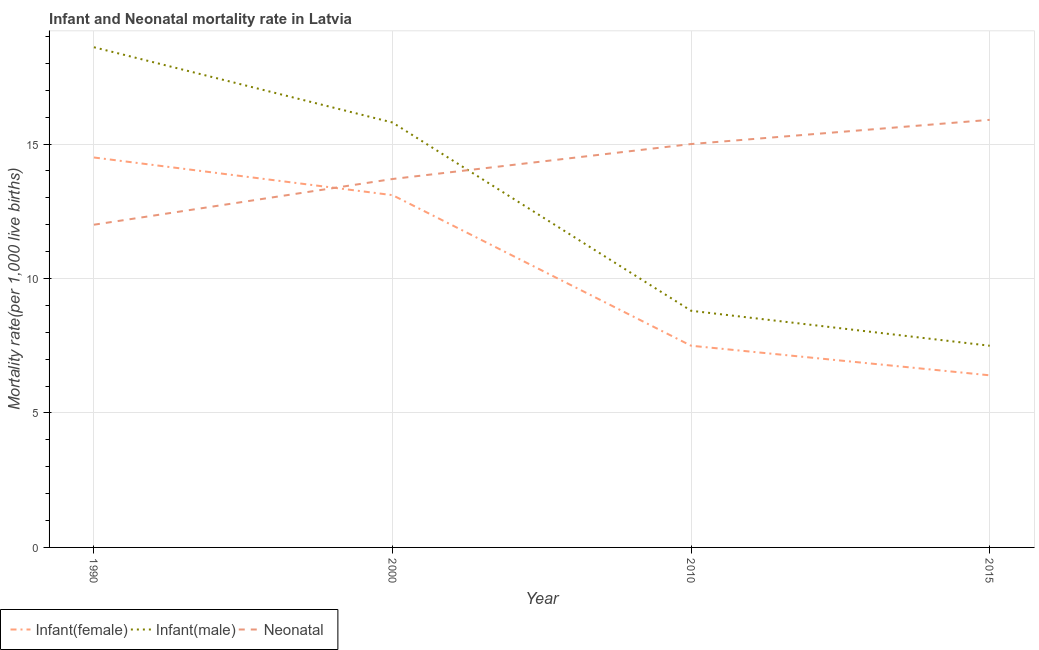How many different coloured lines are there?
Provide a succinct answer. 3. Is the number of lines equal to the number of legend labels?
Your response must be concise. Yes. What is the infant mortality rate(male) in 2015?
Your response must be concise. 7.5. Across all years, what is the maximum infant mortality rate(male)?
Your answer should be compact. 18.6. Across all years, what is the minimum neonatal mortality rate?
Ensure brevity in your answer.  12. In which year was the infant mortality rate(male) maximum?
Your response must be concise. 1990. In which year was the neonatal mortality rate minimum?
Make the answer very short. 1990. What is the total infant mortality rate(female) in the graph?
Your response must be concise. 41.5. What is the difference between the infant mortality rate(female) in 2010 and that in 2015?
Give a very brief answer. 1.1. What is the difference between the neonatal mortality rate in 1990 and the infant mortality rate(male) in 2000?
Your answer should be very brief. -3.8. What is the average infant mortality rate(male) per year?
Provide a short and direct response. 12.68. In the year 2000, what is the difference between the neonatal mortality rate and infant mortality rate(male)?
Your response must be concise. -2.1. What is the ratio of the infant mortality rate(female) in 1990 to that in 2010?
Provide a short and direct response. 1.93. Is the difference between the neonatal mortality rate in 2000 and 2010 greater than the difference between the infant mortality rate(male) in 2000 and 2010?
Provide a succinct answer. No. What is the difference between the highest and the second highest infant mortality rate(male)?
Offer a very short reply. 2.8. What is the difference between the highest and the lowest neonatal mortality rate?
Your answer should be compact. 3.9. In how many years, is the infant mortality rate(female) greater than the average infant mortality rate(female) taken over all years?
Keep it short and to the point. 2. Is the sum of the infant mortality rate(female) in 2000 and 2010 greater than the maximum neonatal mortality rate across all years?
Offer a terse response. Yes. What is the difference between two consecutive major ticks on the Y-axis?
Provide a succinct answer. 5. Are the values on the major ticks of Y-axis written in scientific E-notation?
Offer a terse response. No. Does the graph contain grids?
Offer a very short reply. Yes. Where does the legend appear in the graph?
Your answer should be compact. Bottom left. What is the title of the graph?
Provide a succinct answer. Infant and Neonatal mortality rate in Latvia. What is the label or title of the X-axis?
Provide a succinct answer. Year. What is the label or title of the Y-axis?
Your answer should be compact. Mortality rate(per 1,0 live births). What is the Mortality rate(per 1,000 live births) of Neonatal  in 1990?
Offer a terse response. 12. What is the Mortality rate(per 1,000 live births) in Infant(female) in 2000?
Provide a short and direct response. 13.1. What is the Mortality rate(per 1,000 live births) in Infant(male) in 2000?
Offer a terse response. 15.8. What is the Mortality rate(per 1,000 live births) of Neonatal  in 2010?
Ensure brevity in your answer.  15. What is the Mortality rate(per 1,000 live births) of Infant(female) in 2015?
Keep it short and to the point. 6.4. What is the Mortality rate(per 1,000 live births) in Neonatal  in 2015?
Ensure brevity in your answer.  15.9. Across all years, what is the maximum Mortality rate(per 1,000 live births) of Infant(female)?
Your response must be concise. 14.5. Across all years, what is the maximum Mortality rate(per 1,000 live births) in Infant(male)?
Your answer should be compact. 18.6. What is the total Mortality rate(per 1,000 live births) in Infant(female) in the graph?
Keep it short and to the point. 41.5. What is the total Mortality rate(per 1,000 live births) in Infant(male) in the graph?
Provide a short and direct response. 50.7. What is the total Mortality rate(per 1,000 live births) of Neonatal  in the graph?
Provide a succinct answer. 56.6. What is the difference between the Mortality rate(per 1,000 live births) in Infant(female) in 1990 and that in 2000?
Keep it short and to the point. 1.4. What is the difference between the Mortality rate(per 1,000 live births) of Neonatal  in 1990 and that in 2000?
Offer a very short reply. -1.7. What is the difference between the Mortality rate(per 1,000 live births) in Infant(female) in 1990 and that in 2010?
Your answer should be compact. 7. What is the difference between the Mortality rate(per 1,000 live births) of Infant(male) in 1990 and that in 2010?
Your answer should be very brief. 9.8. What is the difference between the Mortality rate(per 1,000 live births) in Infant(female) in 1990 and that in 2015?
Offer a very short reply. 8.1. What is the difference between the Mortality rate(per 1,000 live births) of Infant(male) in 2000 and that in 2010?
Your answer should be compact. 7. What is the difference between the Mortality rate(per 1,000 live births) in Infant(male) in 2000 and that in 2015?
Keep it short and to the point. 8.3. What is the difference between the Mortality rate(per 1,000 live births) of Neonatal  in 2000 and that in 2015?
Keep it short and to the point. -2.2. What is the difference between the Mortality rate(per 1,000 live births) of Infant(female) in 2010 and that in 2015?
Provide a succinct answer. 1.1. What is the difference between the Mortality rate(per 1,000 live births) of Infant(female) in 1990 and the Mortality rate(per 1,000 live births) of Neonatal  in 2000?
Provide a short and direct response. 0.8. What is the difference between the Mortality rate(per 1,000 live births) in Infant(female) in 1990 and the Mortality rate(per 1,000 live births) in Infant(male) in 2010?
Your response must be concise. 5.7. What is the difference between the Mortality rate(per 1,000 live births) of Infant(female) in 1990 and the Mortality rate(per 1,000 live births) of Neonatal  in 2010?
Your answer should be very brief. -0.5. What is the difference between the Mortality rate(per 1,000 live births) in Infant(male) in 1990 and the Mortality rate(per 1,000 live births) in Neonatal  in 2010?
Your answer should be very brief. 3.6. What is the difference between the Mortality rate(per 1,000 live births) of Infant(male) in 1990 and the Mortality rate(per 1,000 live births) of Neonatal  in 2015?
Your answer should be very brief. 2.7. What is the difference between the Mortality rate(per 1,000 live births) of Infant(female) in 2000 and the Mortality rate(per 1,000 live births) of Neonatal  in 2010?
Ensure brevity in your answer.  -1.9. What is the difference between the Mortality rate(per 1,000 live births) of Infant(female) in 2000 and the Mortality rate(per 1,000 live births) of Infant(male) in 2015?
Your response must be concise. 5.6. What is the difference between the Mortality rate(per 1,000 live births) in Infant(female) in 2000 and the Mortality rate(per 1,000 live births) in Neonatal  in 2015?
Your response must be concise. -2.8. What is the difference between the Mortality rate(per 1,000 live births) in Infant(female) in 2010 and the Mortality rate(per 1,000 live births) in Infant(male) in 2015?
Ensure brevity in your answer.  0. What is the average Mortality rate(per 1,000 live births) of Infant(female) per year?
Offer a very short reply. 10.38. What is the average Mortality rate(per 1,000 live births) of Infant(male) per year?
Ensure brevity in your answer.  12.68. What is the average Mortality rate(per 1,000 live births) of Neonatal  per year?
Provide a succinct answer. 14.15. In the year 1990, what is the difference between the Mortality rate(per 1,000 live births) in Infant(female) and Mortality rate(per 1,000 live births) in Neonatal ?
Your answer should be compact. 2.5. In the year 2010, what is the difference between the Mortality rate(per 1,000 live births) of Infant(female) and Mortality rate(per 1,000 live births) of Infant(male)?
Your response must be concise. -1.3. In the year 2010, what is the difference between the Mortality rate(per 1,000 live births) of Infant(female) and Mortality rate(per 1,000 live births) of Neonatal ?
Provide a short and direct response. -7.5. In the year 2015, what is the difference between the Mortality rate(per 1,000 live births) in Infant(female) and Mortality rate(per 1,000 live births) in Neonatal ?
Provide a short and direct response. -9.5. In the year 2015, what is the difference between the Mortality rate(per 1,000 live births) of Infant(male) and Mortality rate(per 1,000 live births) of Neonatal ?
Give a very brief answer. -8.4. What is the ratio of the Mortality rate(per 1,000 live births) in Infant(female) in 1990 to that in 2000?
Provide a succinct answer. 1.11. What is the ratio of the Mortality rate(per 1,000 live births) of Infant(male) in 1990 to that in 2000?
Keep it short and to the point. 1.18. What is the ratio of the Mortality rate(per 1,000 live births) of Neonatal  in 1990 to that in 2000?
Make the answer very short. 0.88. What is the ratio of the Mortality rate(per 1,000 live births) of Infant(female) in 1990 to that in 2010?
Give a very brief answer. 1.93. What is the ratio of the Mortality rate(per 1,000 live births) of Infant(male) in 1990 to that in 2010?
Offer a very short reply. 2.11. What is the ratio of the Mortality rate(per 1,000 live births) in Neonatal  in 1990 to that in 2010?
Make the answer very short. 0.8. What is the ratio of the Mortality rate(per 1,000 live births) of Infant(female) in 1990 to that in 2015?
Offer a very short reply. 2.27. What is the ratio of the Mortality rate(per 1,000 live births) of Infant(male) in 1990 to that in 2015?
Your response must be concise. 2.48. What is the ratio of the Mortality rate(per 1,000 live births) in Neonatal  in 1990 to that in 2015?
Offer a terse response. 0.75. What is the ratio of the Mortality rate(per 1,000 live births) of Infant(female) in 2000 to that in 2010?
Ensure brevity in your answer.  1.75. What is the ratio of the Mortality rate(per 1,000 live births) in Infant(male) in 2000 to that in 2010?
Provide a succinct answer. 1.8. What is the ratio of the Mortality rate(per 1,000 live births) in Neonatal  in 2000 to that in 2010?
Keep it short and to the point. 0.91. What is the ratio of the Mortality rate(per 1,000 live births) of Infant(female) in 2000 to that in 2015?
Your answer should be very brief. 2.05. What is the ratio of the Mortality rate(per 1,000 live births) in Infant(male) in 2000 to that in 2015?
Offer a very short reply. 2.11. What is the ratio of the Mortality rate(per 1,000 live births) in Neonatal  in 2000 to that in 2015?
Ensure brevity in your answer.  0.86. What is the ratio of the Mortality rate(per 1,000 live births) of Infant(female) in 2010 to that in 2015?
Your answer should be very brief. 1.17. What is the ratio of the Mortality rate(per 1,000 live births) in Infant(male) in 2010 to that in 2015?
Provide a succinct answer. 1.17. What is the ratio of the Mortality rate(per 1,000 live births) in Neonatal  in 2010 to that in 2015?
Make the answer very short. 0.94. What is the difference between the highest and the second highest Mortality rate(per 1,000 live births) of Infant(female)?
Your answer should be very brief. 1.4. What is the difference between the highest and the lowest Mortality rate(per 1,000 live births) of Infant(female)?
Your response must be concise. 8.1. What is the difference between the highest and the lowest Mortality rate(per 1,000 live births) in Infant(male)?
Give a very brief answer. 11.1. 